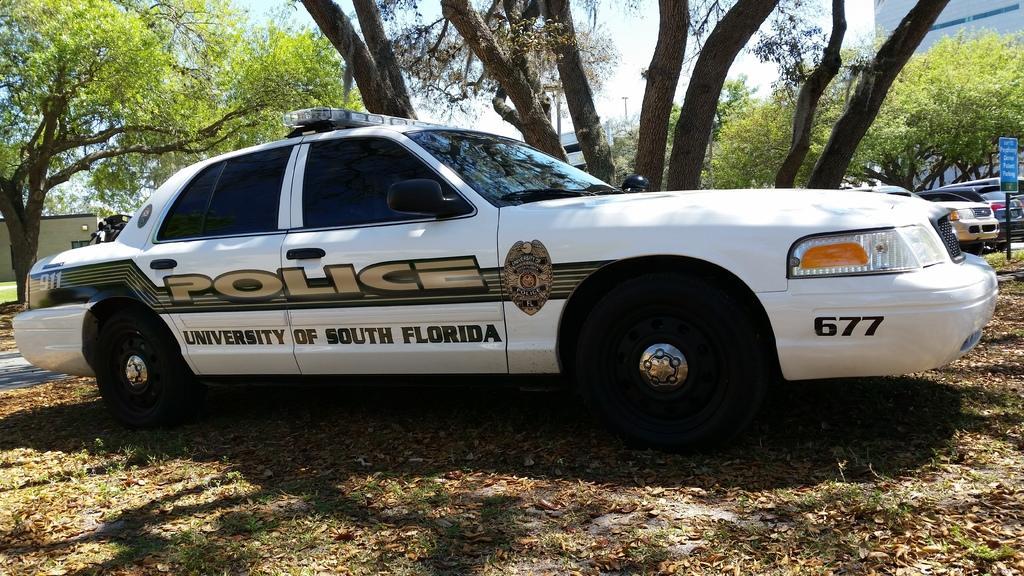In one or two sentences, can you explain what this image depicts? In this image there is a police car on the land having grass and few dried leaves on it. Behind car there are trees. Right side there are few vehicles on the road. There is a pole having a board is on the land. In background there are few trees and buildings. Top of image there is sky. 